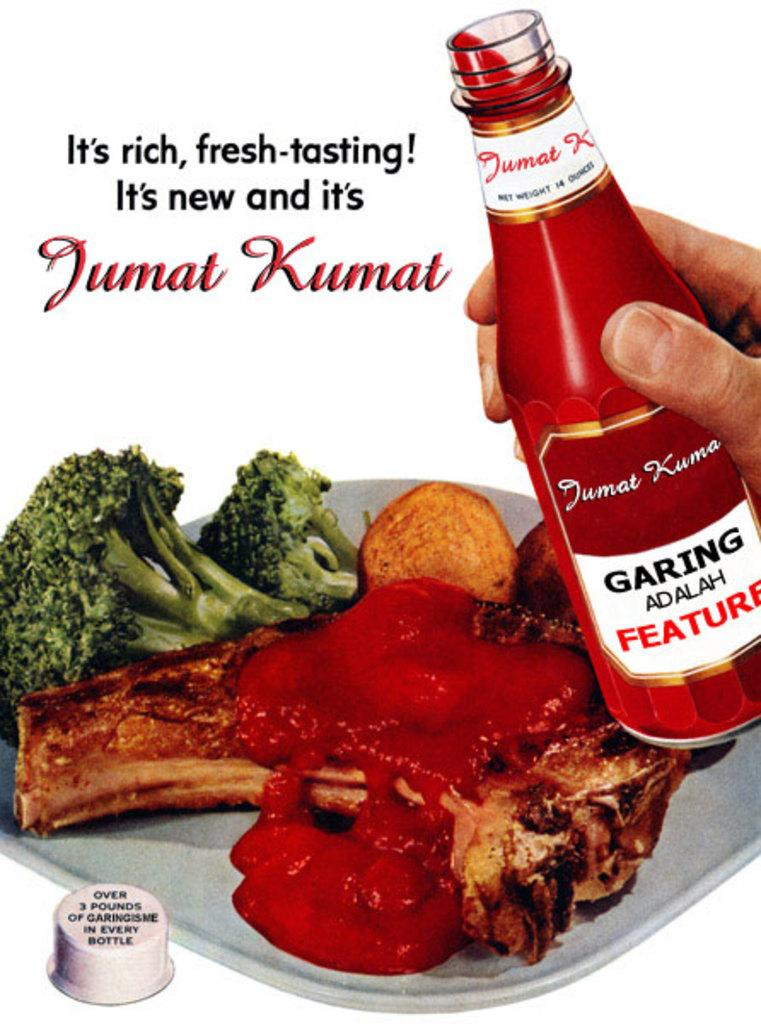<image>
Provide a brief description of the given image. A classic-looking advertisement for Jumat Kumat, which appears to be a ketchup-like sauce. 